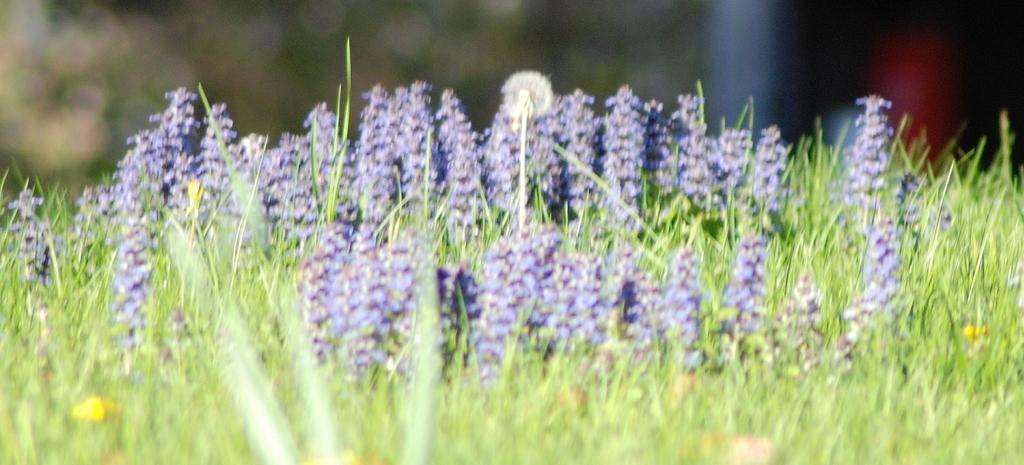Could you give a brief overview of what you see in this image? In this image in the front there is grass. In the center there are flowers and the background is blurry. 